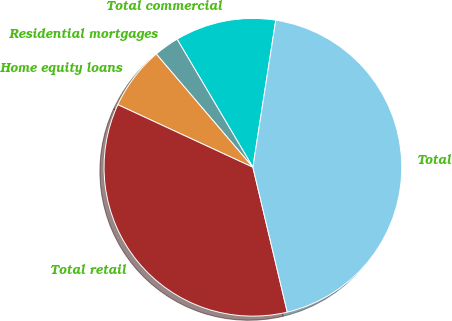Convert chart. <chart><loc_0><loc_0><loc_500><loc_500><pie_chart><fcel>Total commercial<fcel>Residential mortgages<fcel>Home equity loans<fcel>Total retail<fcel>Total<nl><fcel>10.96%<fcel>2.74%<fcel>6.85%<fcel>35.62%<fcel>43.84%<nl></chart> 